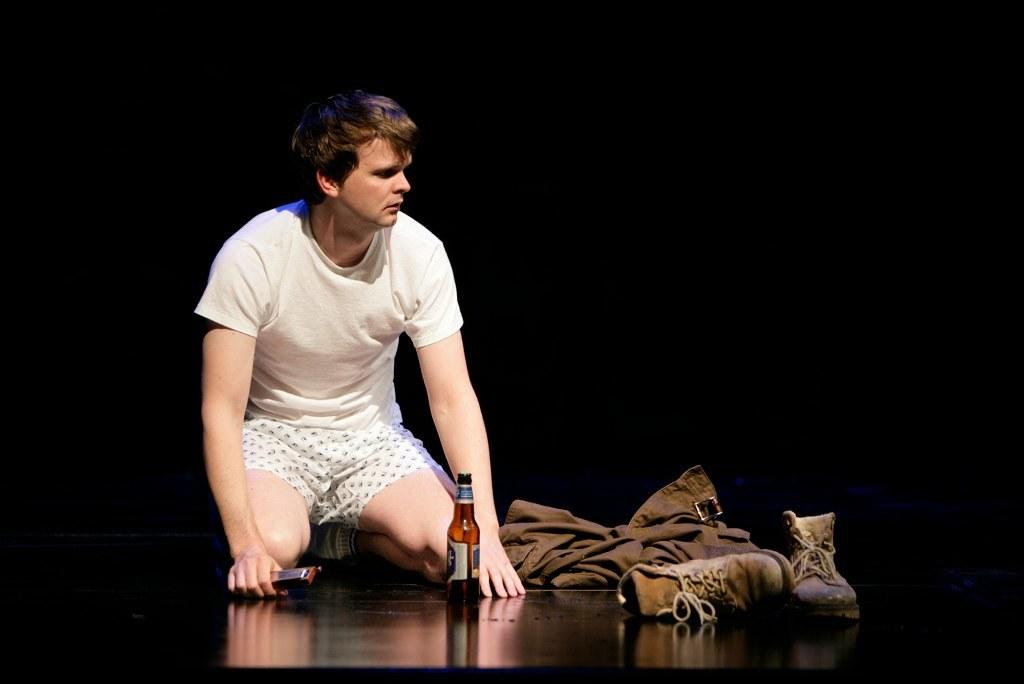What is the person in the image doing? The person is on the floor in the image. What can be seen on the right side of the image? There is a jacket and shoes on the right side of the image. What object is present in the image that might contain a liquid? There is a bottle in the image. How many dolls are sitting on the low shelf in the image? There are no dolls or shelves present in the image. 